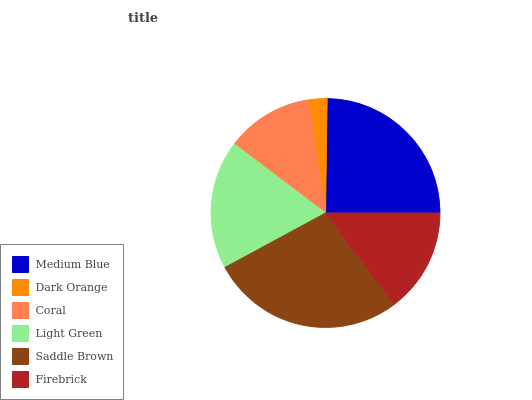Is Dark Orange the minimum?
Answer yes or no. Yes. Is Saddle Brown the maximum?
Answer yes or no. Yes. Is Coral the minimum?
Answer yes or no. No. Is Coral the maximum?
Answer yes or no. No. Is Coral greater than Dark Orange?
Answer yes or no. Yes. Is Dark Orange less than Coral?
Answer yes or no. Yes. Is Dark Orange greater than Coral?
Answer yes or no. No. Is Coral less than Dark Orange?
Answer yes or no. No. Is Light Green the high median?
Answer yes or no. Yes. Is Firebrick the low median?
Answer yes or no. Yes. Is Saddle Brown the high median?
Answer yes or no. No. Is Coral the low median?
Answer yes or no. No. 